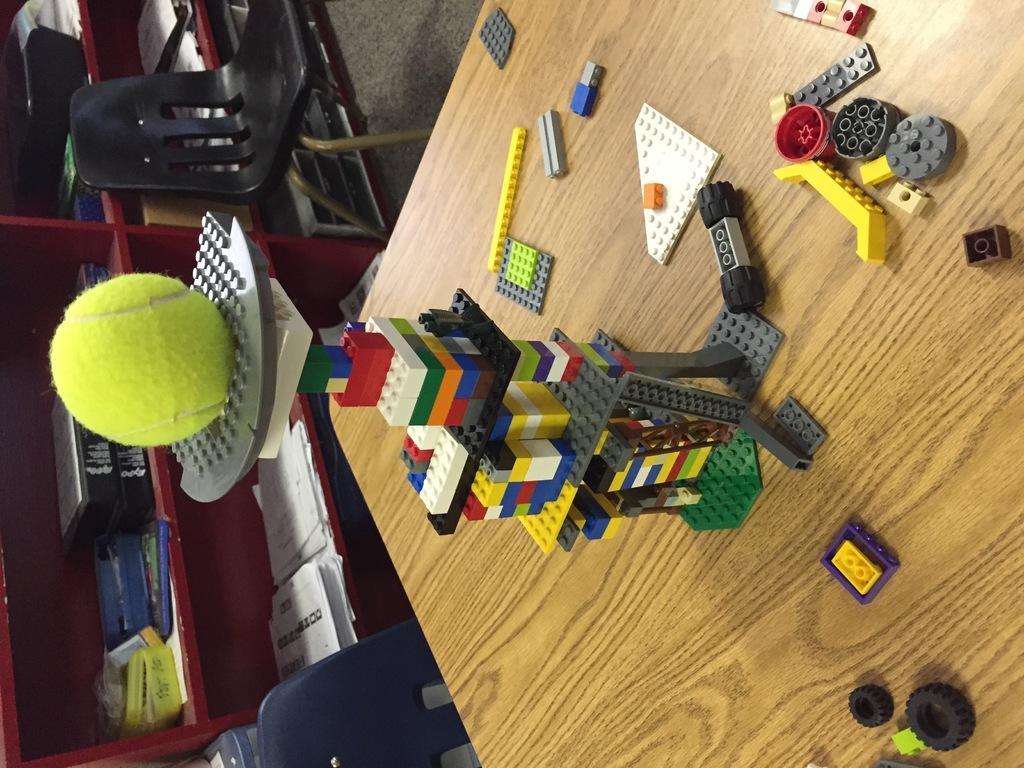In one or two sentences, can you explain what this image depicts? In this image we can see a tennis ball placed on group of Lego toys on the table. In the background, we can see group of books and papers placed in racks and chairs placed on the ground. 